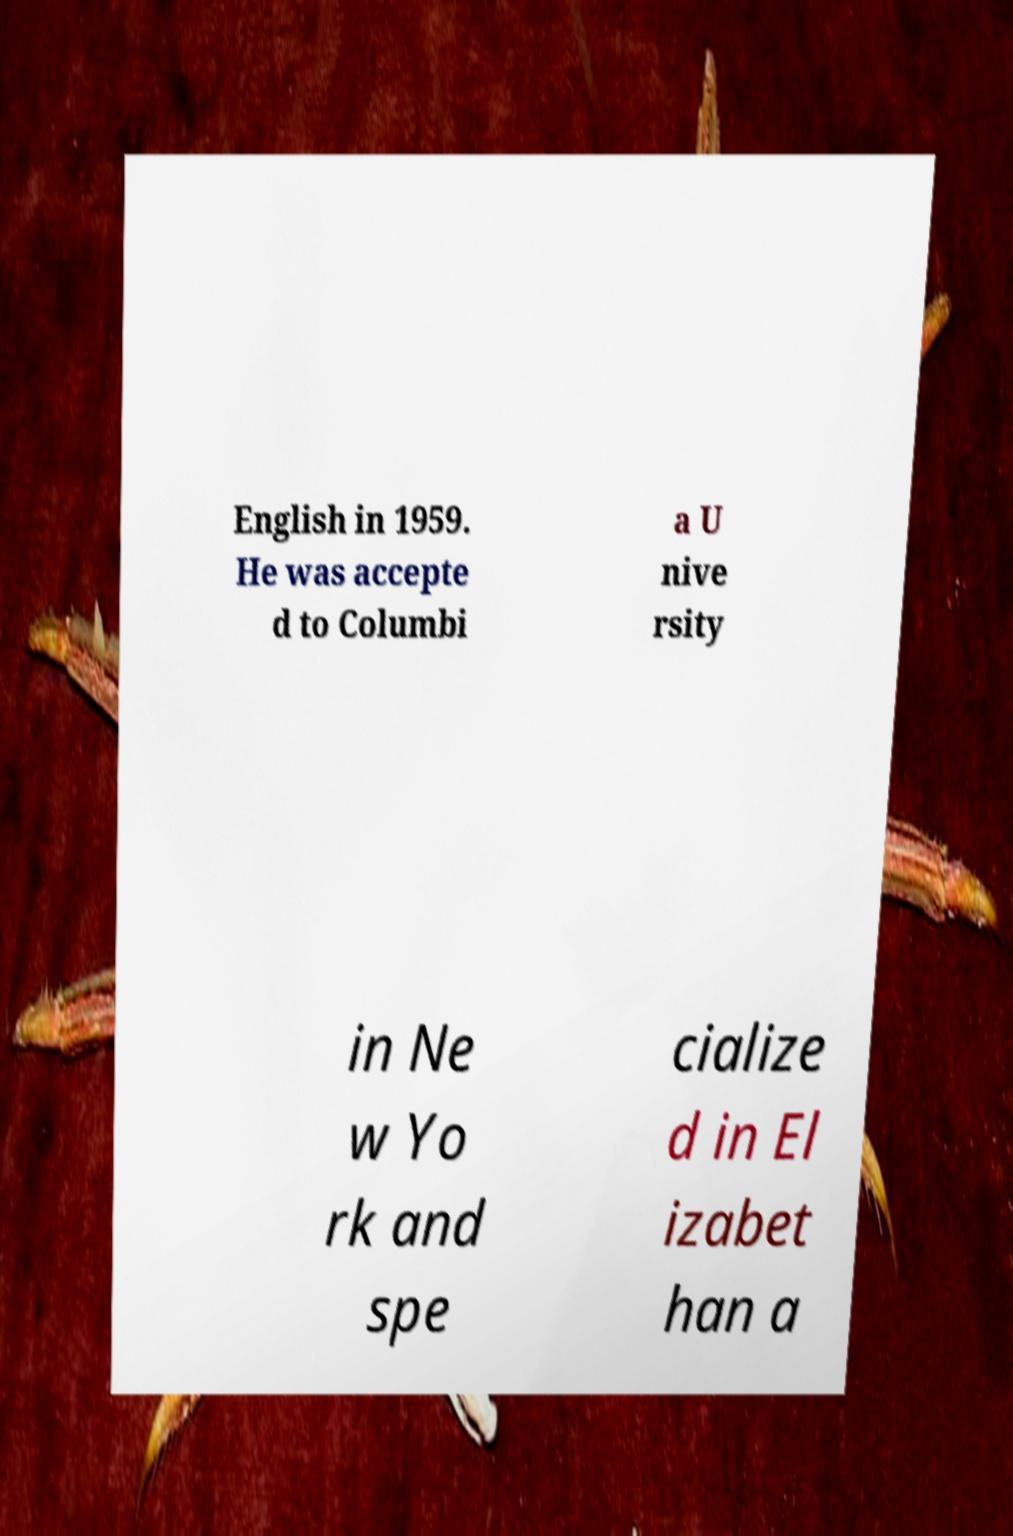Could you extract and type out the text from this image? English in 1959. He was accepte d to Columbi a U nive rsity in Ne w Yo rk and spe cialize d in El izabet han a 